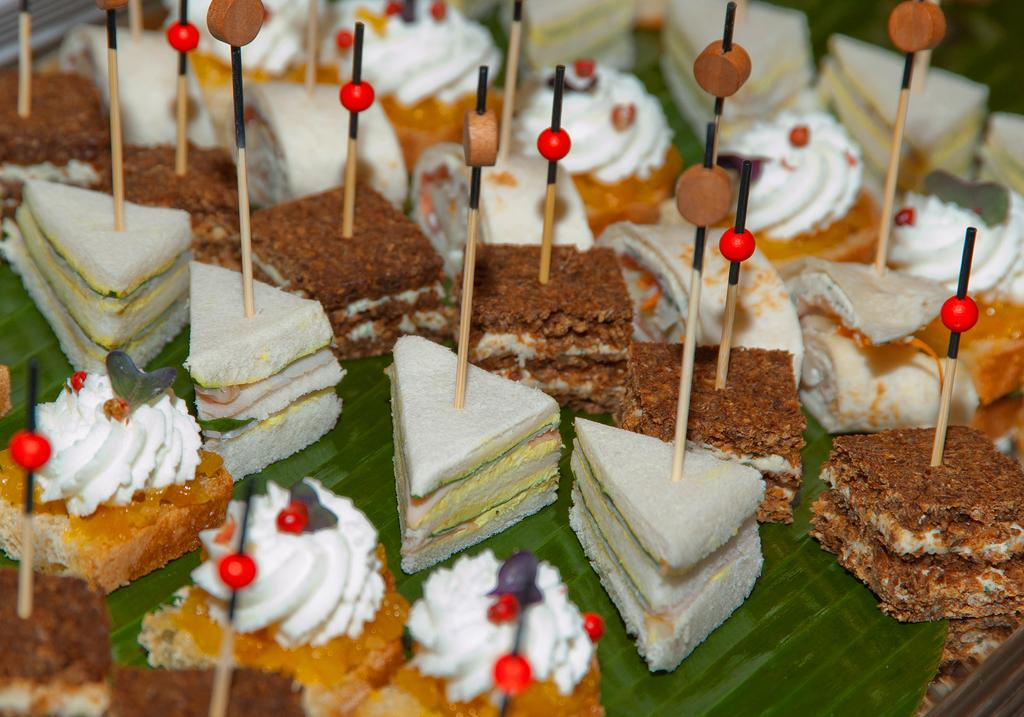What can be seen in the image in terms of food? There are different types of food in the image. Can you describe any specific details about the food items? Most of the food items have stocks on them. How many trees can be seen in the image? There are no trees visible in the image; it only features different types of food with stocks on them. 